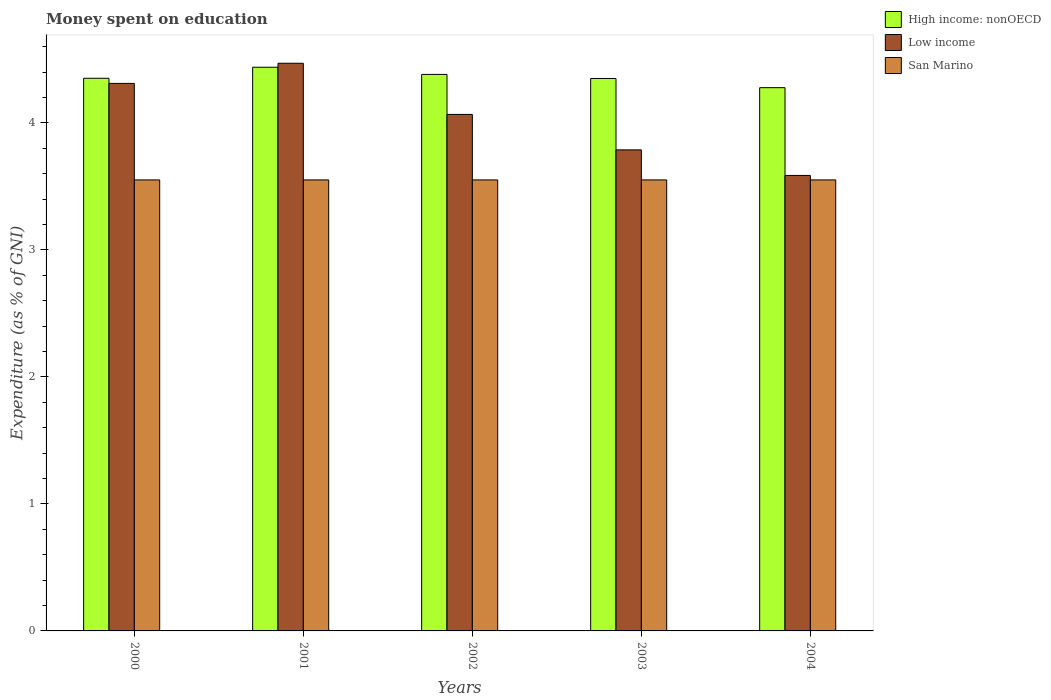How many different coloured bars are there?
Ensure brevity in your answer.  3. How many groups of bars are there?
Your answer should be compact. 5. Are the number of bars on each tick of the X-axis equal?
Your response must be concise. Yes. What is the label of the 2nd group of bars from the left?
Make the answer very short. 2001. What is the amount of money spent on education in San Marino in 2002?
Offer a terse response. 3.55. Across all years, what is the maximum amount of money spent on education in San Marino?
Your answer should be compact. 3.55. Across all years, what is the minimum amount of money spent on education in San Marino?
Ensure brevity in your answer.  3.55. What is the total amount of money spent on education in San Marino in the graph?
Offer a terse response. 17.75. What is the difference between the amount of money spent on education in High income: nonOECD in 2002 and that in 2004?
Your answer should be compact. 0.1. What is the difference between the amount of money spent on education in San Marino in 2003 and the amount of money spent on education in Low income in 2004?
Your answer should be compact. -0.04. What is the average amount of money spent on education in High income: nonOECD per year?
Offer a very short reply. 4.36. In the year 2000, what is the difference between the amount of money spent on education in High income: nonOECD and amount of money spent on education in San Marino?
Make the answer very short. 0.8. What is the ratio of the amount of money spent on education in Low income in 2002 to that in 2003?
Provide a succinct answer. 1.07. Is the difference between the amount of money spent on education in High income: nonOECD in 2000 and 2004 greater than the difference between the amount of money spent on education in San Marino in 2000 and 2004?
Provide a short and direct response. Yes. What is the difference between the highest and the second highest amount of money spent on education in Low income?
Your answer should be very brief. 0.16. What is the difference between the highest and the lowest amount of money spent on education in High income: nonOECD?
Provide a short and direct response. 0.16. What does the 2nd bar from the left in 2002 represents?
Make the answer very short. Low income. How many bars are there?
Your answer should be compact. 15. Are all the bars in the graph horizontal?
Ensure brevity in your answer.  No. How many years are there in the graph?
Provide a succinct answer. 5. Does the graph contain grids?
Offer a terse response. No. Where does the legend appear in the graph?
Provide a succinct answer. Top right. How many legend labels are there?
Provide a short and direct response. 3. What is the title of the graph?
Offer a very short reply. Money spent on education. Does "Cyprus" appear as one of the legend labels in the graph?
Ensure brevity in your answer.  No. What is the label or title of the Y-axis?
Your answer should be compact. Expenditure (as % of GNI). What is the Expenditure (as % of GNI) in High income: nonOECD in 2000?
Your response must be concise. 4.35. What is the Expenditure (as % of GNI) of Low income in 2000?
Give a very brief answer. 4.31. What is the Expenditure (as % of GNI) of San Marino in 2000?
Offer a very short reply. 3.55. What is the Expenditure (as % of GNI) in High income: nonOECD in 2001?
Ensure brevity in your answer.  4.44. What is the Expenditure (as % of GNI) of Low income in 2001?
Your response must be concise. 4.47. What is the Expenditure (as % of GNI) of San Marino in 2001?
Offer a terse response. 3.55. What is the Expenditure (as % of GNI) of High income: nonOECD in 2002?
Provide a short and direct response. 4.38. What is the Expenditure (as % of GNI) of Low income in 2002?
Offer a terse response. 4.07. What is the Expenditure (as % of GNI) of San Marino in 2002?
Provide a succinct answer. 3.55. What is the Expenditure (as % of GNI) in High income: nonOECD in 2003?
Your response must be concise. 4.35. What is the Expenditure (as % of GNI) of Low income in 2003?
Offer a terse response. 3.79. What is the Expenditure (as % of GNI) of San Marino in 2003?
Give a very brief answer. 3.55. What is the Expenditure (as % of GNI) in High income: nonOECD in 2004?
Your answer should be compact. 4.28. What is the Expenditure (as % of GNI) of Low income in 2004?
Your answer should be compact. 3.59. What is the Expenditure (as % of GNI) of San Marino in 2004?
Your answer should be compact. 3.55. Across all years, what is the maximum Expenditure (as % of GNI) in High income: nonOECD?
Offer a very short reply. 4.44. Across all years, what is the maximum Expenditure (as % of GNI) of Low income?
Your answer should be very brief. 4.47. Across all years, what is the maximum Expenditure (as % of GNI) in San Marino?
Your response must be concise. 3.55. Across all years, what is the minimum Expenditure (as % of GNI) in High income: nonOECD?
Provide a short and direct response. 4.28. Across all years, what is the minimum Expenditure (as % of GNI) in Low income?
Provide a short and direct response. 3.59. Across all years, what is the minimum Expenditure (as % of GNI) in San Marino?
Provide a short and direct response. 3.55. What is the total Expenditure (as % of GNI) in High income: nonOECD in the graph?
Your answer should be very brief. 21.8. What is the total Expenditure (as % of GNI) in Low income in the graph?
Offer a very short reply. 20.22. What is the total Expenditure (as % of GNI) in San Marino in the graph?
Make the answer very short. 17.75. What is the difference between the Expenditure (as % of GNI) of High income: nonOECD in 2000 and that in 2001?
Make the answer very short. -0.09. What is the difference between the Expenditure (as % of GNI) in Low income in 2000 and that in 2001?
Provide a short and direct response. -0.16. What is the difference between the Expenditure (as % of GNI) in San Marino in 2000 and that in 2001?
Keep it short and to the point. 0. What is the difference between the Expenditure (as % of GNI) of High income: nonOECD in 2000 and that in 2002?
Offer a terse response. -0.03. What is the difference between the Expenditure (as % of GNI) in Low income in 2000 and that in 2002?
Offer a very short reply. 0.24. What is the difference between the Expenditure (as % of GNI) in San Marino in 2000 and that in 2002?
Ensure brevity in your answer.  0. What is the difference between the Expenditure (as % of GNI) in High income: nonOECD in 2000 and that in 2003?
Provide a succinct answer. 0. What is the difference between the Expenditure (as % of GNI) in Low income in 2000 and that in 2003?
Offer a terse response. 0.52. What is the difference between the Expenditure (as % of GNI) in San Marino in 2000 and that in 2003?
Your answer should be compact. 0. What is the difference between the Expenditure (as % of GNI) in High income: nonOECD in 2000 and that in 2004?
Your response must be concise. 0.07. What is the difference between the Expenditure (as % of GNI) of Low income in 2000 and that in 2004?
Provide a short and direct response. 0.72. What is the difference between the Expenditure (as % of GNI) of San Marino in 2000 and that in 2004?
Your answer should be compact. 0. What is the difference between the Expenditure (as % of GNI) of High income: nonOECD in 2001 and that in 2002?
Provide a short and direct response. 0.06. What is the difference between the Expenditure (as % of GNI) in Low income in 2001 and that in 2002?
Offer a very short reply. 0.4. What is the difference between the Expenditure (as % of GNI) in High income: nonOECD in 2001 and that in 2003?
Your answer should be compact. 0.09. What is the difference between the Expenditure (as % of GNI) of Low income in 2001 and that in 2003?
Your answer should be very brief. 0.68. What is the difference between the Expenditure (as % of GNI) in San Marino in 2001 and that in 2003?
Provide a succinct answer. 0. What is the difference between the Expenditure (as % of GNI) of High income: nonOECD in 2001 and that in 2004?
Give a very brief answer. 0.16. What is the difference between the Expenditure (as % of GNI) of Low income in 2001 and that in 2004?
Ensure brevity in your answer.  0.88. What is the difference between the Expenditure (as % of GNI) in High income: nonOECD in 2002 and that in 2003?
Give a very brief answer. 0.03. What is the difference between the Expenditure (as % of GNI) of Low income in 2002 and that in 2003?
Make the answer very short. 0.28. What is the difference between the Expenditure (as % of GNI) in San Marino in 2002 and that in 2003?
Your answer should be compact. 0. What is the difference between the Expenditure (as % of GNI) in High income: nonOECD in 2002 and that in 2004?
Your response must be concise. 0.1. What is the difference between the Expenditure (as % of GNI) in Low income in 2002 and that in 2004?
Keep it short and to the point. 0.48. What is the difference between the Expenditure (as % of GNI) in High income: nonOECD in 2003 and that in 2004?
Your response must be concise. 0.07. What is the difference between the Expenditure (as % of GNI) in Low income in 2003 and that in 2004?
Make the answer very short. 0.2. What is the difference between the Expenditure (as % of GNI) of High income: nonOECD in 2000 and the Expenditure (as % of GNI) of Low income in 2001?
Your response must be concise. -0.12. What is the difference between the Expenditure (as % of GNI) in High income: nonOECD in 2000 and the Expenditure (as % of GNI) in San Marino in 2001?
Your answer should be very brief. 0.8. What is the difference between the Expenditure (as % of GNI) of Low income in 2000 and the Expenditure (as % of GNI) of San Marino in 2001?
Provide a succinct answer. 0.76. What is the difference between the Expenditure (as % of GNI) of High income: nonOECD in 2000 and the Expenditure (as % of GNI) of Low income in 2002?
Provide a short and direct response. 0.28. What is the difference between the Expenditure (as % of GNI) of High income: nonOECD in 2000 and the Expenditure (as % of GNI) of San Marino in 2002?
Offer a terse response. 0.8. What is the difference between the Expenditure (as % of GNI) in Low income in 2000 and the Expenditure (as % of GNI) in San Marino in 2002?
Ensure brevity in your answer.  0.76. What is the difference between the Expenditure (as % of GNI) in High income: nonOECD in 2000 and the Expenditure (as % of GNI) in Low income in 2003?
Your answer should be very brief. 0.56. What is the difference between the Expenditure (as % of GNI) of High income: nonOECD in 2000 and the Expenditure (as % of GNI) of San Marino in 2003?
Give a very brief answer. 0.8. What is the difference between the Expenditure (as % of GNI) of Low income in 2000 and the Expenditure (as % of GNI) of San Marino in 2003?
Make the answer very short. 0.76. What is the difference between the Expenditure (as % of GNI) of High income: nonOECD in 2000 and the Expenditure (as % of GNI) of Low income in 2004?
Offer a very short reply. 0.77. What is the difference between the Expenditure (as % of GNI) of High income: nonOECD in 2000 and the Expenditure (as % of GNI) of San Marino in 2004?
Ensure brevity in your answer.  0.8. What is the difference between the Expenditure (as % of GNI) of Low income in 2000 and the Expenditure (as % of GNI) of San Marino in 2004?
Provide a short and direct response. 0.76. What is the difference between the Expenditure (as % of GNI) of High income: nonOECD in 2001 and the Expenditure (as % of GNI) of Low income in 2002?
Keep it short and to the point. 0.37. What is the difference between the Expenditure (as % of GNI) of High income: nonOECD in 2001 and the Expenditure (as % of GNI) of San Marino in 2002?
Keep it short and to the point. 0.89. What is the difference between the Expenditure (as % of GNI) of Low income in 2001 and the Expenditure (as % of GNI) of San Marino in 2002?
Keep it short and to the point. 0.92. What is the difference between the Expenditure (as % of GNI) of High income: nonOECD in 2001 and the Expenditure (as % of GNI) of Low income in 2003?
Your response must be concise. 0.65. What is the difference between the Expenditure (as % of GNI) of High income: nonOECD in 2001 and the Expenditure (as % of GNI) of San Marino in 2003?
Make the answer very short. 0.89. What is the difference between the Expenditure (as % of GNI) of Low income in 2001 and the Expenditure (as % of GNI) of San Marino in 2003?
Give a very brief answer. 0.92. What is the difference between the Expenditure (as % of GNI) of High income: nonOECD in 2001 and the Expenditure (as % of GNI) of Low income in 2004?
Offer a very short reply. 0.85. What is the difference between the Expenditure (as % of GNI) in High income: nonOECD in 2001 and the Expenditure (as % of GNI) in San Marino in 2004?
Offer a terse response. 0.89. What is the difference between the Expenditure (as % of GNI) in Low income in 2001 and the Expenditure (as % of GNI) in San Marino in 2004?
Provide a succinct answer. 0.92. What is the difference between the Expenditure (as % of GNI) of High income: nonOECD in 2002 and the Expenditure (as % of GNI) of Low income in 2003?
Your answer should be compact. 0.59. What is the difference between the Expenditure (as % of GNI) in High income: nonOECD in 2002 and the Expenditure (as % of GNI) in San Marino in 2003?
Your answer should be compact. 0.83. What is the difference between the Expenditure (as % of GNI) of Low income in 2002 and the Expenditure (as % of GNI) of San Marino in 2003?
Offer a terse response. 0.52. What is the difference between the Expenditure (as % of GNI) of High income: nonOECD in 2002 and the Expenditure (as % of GNI) of Low income in 2004?
Offer a terse response. 0.8. What is the difference between the Expenditure (as % of GNI) in High income: nonOECD in 2002 and the Expenditure (as % of GNI) in San Marino in 2004?
Your response must be concise. 0.83. What is the difference between the Expenditure (as % of GNI) in Low income in 2002 and the Expenditure (as % of GNI) in San Marino in 2004?
Give a very brief answer. 0.52. What is the difference between the Expenditure (as % of GNI) of High income: nonOECD in 2003 and the Expenditure (as % of GNI) of Low income in 2004?
Offer a very short reply. 0.76. What is the difference between the Expenditure (as % of GNI) of High income: nonOECD in 2003 and the Expenditure (as % of GNI) of San Marino in 2004?
Offer a terse response. 0.8. What is the difference between the Expenditure (as % of GNI) in Low income in 2003 and the Expenditure (as % of GNI) in San Marino in 2004?
Your response must be concise. 0.24. What is the average Expenditure (as % of GNI) of High income: nonOECD per year?
Provide a short and direct response. 4.36. What is the average Expenditure (as % of GNI) of Low income per year?
Ensure brevity in your answer.  4.04. What is the average Expenditure (as % of GNI) of San Marino per year?
Your answer should be very brief. 3.55. In the year 2000, what is the difference between the Expenditure (as % of GNI) in High income: nonOECD and Expenditure (as % of GNI) in Low income?
Your answer should be very brief. 0.04. In the year 2000, what is the difference between the Expenditure (as % of GNI) in High income: nonOECD and Expenditure (as % of GNI) in San Marino?
Your response must be concise. 0.8. In the year 2000, what is the difference between the Expenditure (as % of GNI) of Low income and Expenditure (as % of GNI) of San Marino?
Your response must be concise. 0.76. In the year 2001, what is the difference between the Expenditure (as % of GNI) in High income: nonOECD and Expenditure (as % of GNI) in Low income?
Give a very brief answer. -0.03. In the year 2001, what is the difference between the Expenditure (as % of GNI) of High income: nonOECD and Expenditure (as % of GNI) of San Marino?
Give a very brief answer. 0.89. In the year 2001, what is the difference between the Expenditure (as % of GNI) in Low income and Expenditure (as % of GNI) in San Marino?
Provide a short and direct response. 0.92. In the year 2002, what is the difference between the Expenditure (as % of GNI) in High income: nonOECD and Expenditure (as % of GNI) in Low income?
Offer a very short reply. 0.31. In the year 2002, what is the difference between the Expenditure (as % of GNI) of High income: nonOECD and Expenditure (as % of GNI) of San Marino?
Your answer should be very brief. 0.83. In the year 2002, what is the difference between the Expenditure (as % of GNI) of Low income and Expenditure (as % of GNI) of San Marino?
Provide a short and direct response. 0.52. In the year 2003, what is the difference between the Expenditure (as % of GNI) in High income: nonOECD and Expenditure (as % of GNI) in Low income?
Provide a succinct answer. 0.56. In the year 2003, what is the difference between the Expenditure (as % of GNI) of High income: nonOECD and Expenditure (as % of GNI) of San Marino?
Your answer should be very brief. 0.8. In the year 2003, what is the difference between the Expenditure (as % of GNI) of Low income and Expenditure (as % of GNI) of San Marino?
Your answer should be compact. 0.24. In the year 2004, what is the difference between the Expenditure (as % of GNI) of High income: nonOECD and Expenditure (as % of GNI) of Low income?
Your response must be concise. 0.69. In the year 2004, what is the difference between the Expenditure (as % of GNI) in High income: nonOECD and Expenditure (as % of GNI) in San Marino?
Make the answer very short. 0.73. In the year 2004, what is the difference between the Expenditure (as % of GNI) of Low income and Expenditure (as % of GNI) of San Marino?
Offer a very short reply. 0.04. What is the ratio of the Expenditure (as % of GNI) in High income: nonOECD in 2000 to that in 2001?
Your response must be concise. 0.98. What is the ratio of the Expenditure (as % of GNI) of Low income in 2000 to that in 2001?
Keep it short and to the point. 0.96. What is the ratio of the Expenditure (as % of GNI) of San Marino in 2000 to that in 2001?
Your answer should be very brief. 1. What is the ratio of the Expenditure (as % of GNI) in High income: nonOECD in 2000 to that in 2002?
Keep it short and to the point. 0.99. What is the ratio of the Expenditure (as % of GNI) of Low income in 2000 to that in 2002?
Provide a succinct answer. 1.06. What is the ratio of the Expenditure (as % of GNI) of Low income in 2000 to that in 2003?
Give a very brief answer. 1.14. What is the ratio of the Expenditure (as % of GNI) of High income: nonOECD in 2000 to that in 2004?
Provide a succinct answer. 1.02. What is the ratio of the Expenditure (as % of GNI) of Low income in 2000 to that in 2004?
Provide a succinct answer. 1.2. What is the ratio of the Expenditure (as % of GNI) in High income: nonOECD in 2001 to that in 2002?
Make the answer very short. 1.01. What is the ratio of the Expenditure (as % of GNI) in Low income in 2001 to that in 2002?
Ensure brevity in your answer.  1.1. What is the ratio of the Expenditure (as % of GNI) in San Marino in 2001 to that in 2002?
Keep it short and to the point. 1. What is the ratio of the Expenditure (as % of GNI) of High income: nonOECD in 2001 to that in 2003?
Make the answer very short. 1.02. What is the ratio of the Expenditure (as % of GNI) in Low income in 2001 to that in 2003?
Offer a very short reply. 1.18. What is the ratio of the Expenditure (as % of GNI) in San Marino in 2001 to that in 2003?
Keep it short and to the point. 1. What is the ratio of the Expenditure (as % of GNI) of High income: nonOECD in 2001 to that in 2004?
Keep it short and to the point. 1.04. What is the ratio of the Expenditure (as % of GNI) in Low income in 2001 to that in 2004?
Offer a very short reply. 1.25. What is the ratio of the Expenditure (as % of GNI) of San Marino in 2001 to that in 2004?
Keep it short and to the point. 1. What is the ratio of the Expenditure (as % of GNI) in High income: nonOECD in 2002 to that in 2003?
Offer a terse response. 1.01. What is the ratio of the Expenditure (as % of GNI) in Low income in 2002 to that in 2003?
Provide a succinct answer. 1.07. What is the ratio of the Expenditure (as % of GNI) in San Marino in 2002 to that in 2003?
Your response must be concise. 1. What is the ratio of the Expenditure (as % of GNI) in High income: nonOECD in 2002 to that in 2004?
Offer a very short reply. 1.02. What is the ratio of the Expenditure (as % of GNI) of Low income in 2002 to that in 2004?
Make the answer very short. 1.13. What is the ratio of the Expenditure (as % of GNI) in High income: nonOECD in 2003 to that in 2004?
Give a very brief answer. 1.02. What is the ratio of the Expenditure (as % of GNI) in Low income in 2003 to that in 2004?
Make the answer very short. 1.06. What is the ratio of the Expenditure (as % of GNI) of San Marino in 2003 to that in 2004?
Your answer should be very brief. 1. What is the difference between the highest and the second highest Expenditure (as % of GNI) of High income: nonOECD?
Make the answer very short. 0.06. What is the difference between the highest and the second highest Expenditure (as % of GNI) of Low income?
Offer a very short reply. 0.16. What is the difference between the highest and the lowest Expenditure (as % of GNI) of High income: nonOECD?
Your answer should be very brief. 0.16. What is the difference between the highest and the lowest Expenditure (as % of GNI) of Low income?
Give a very brief answer. 0.88. 